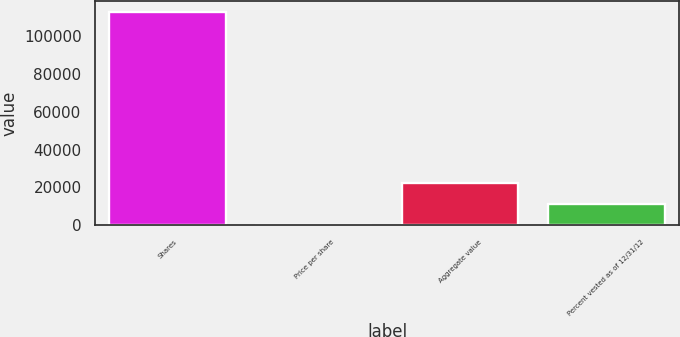<chart> <loc_0><loc_0><loc_500><loc_500><bar_chart><fcel>Shares<fcel>Price per share<fcel>Aggregate value<fcel>Percent vested as of 12/31/12<nl><fcel>112500<fcel>30.87<fcel>22524.7<fcel>11277.8<nl></chart> 